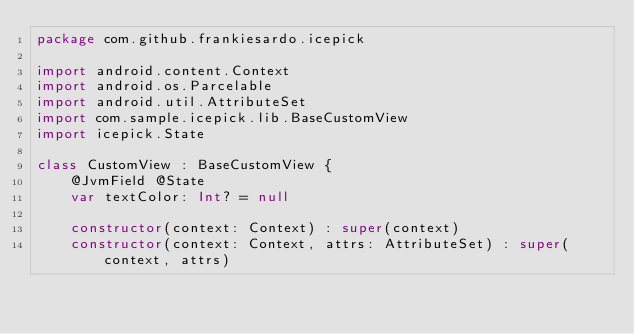Convert code to text. <code><loc_0><loc_0><loc_500><loc_500><_Kotlin_>package com.github.frankiesardo.icepick

import android.content.Context
import android.os.Parcelable
import android.util.AttributeSet
import com.sample.icepick.lib.BaseCustomView
import icepick.State

class CustomView : BaseCustomView {
    @JvmField @State
    var textColor: Int? = null

    constructor(context: Context) : super(context)
    constructor(context: Context, attrs: AttributeSet) : super(context, attrs)</code> 